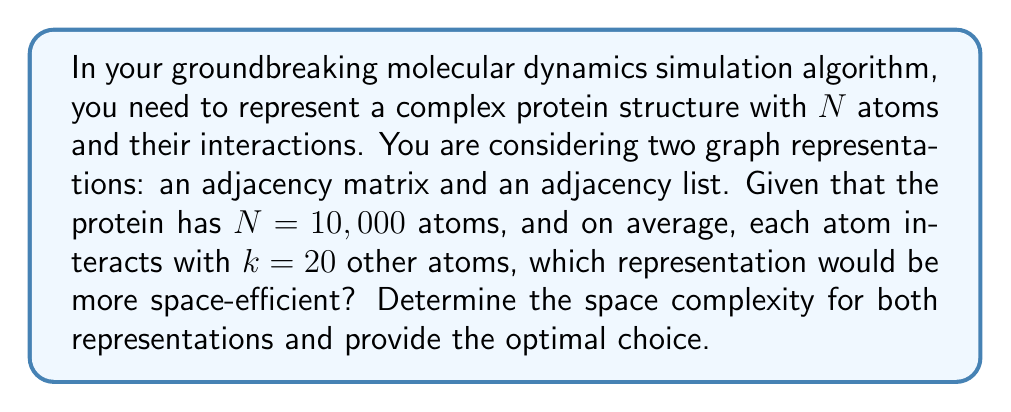Teach me how to tackle this problem. To determine the optimal graph representation, we need to compare the space complexity of adjacency matrix and adjacency list for the given scenario.

1. Adjacency Matrix:
   An adjacency matrix for a graph with $N$ vertices requires $N \times N$ space, regardless of the number of edges.
   Space complexity: $O(N^2)$
   Actual space required: $10,000 \times 10,000 = 10^8$ elements

2. Adjacency List:
   An adjacency list stores a list of adjacent vertices for each vertex. The space required depends on the number of vertices and edges.
   Space complexity: $O(N + E)$, where $E$ is the number of edges
   
   To calculate $E$:
   - Each atom interacts with an average of $k = 20$ other atoms
   - Total interactions: $N \times k = 10,000 \times 20 = 200,000$
   - But this counts each interaction twice (once for each atom involved)
   - So, $E = \frac{N \times k}{2} = \frac{200,000}{2} = 100,000$

   Actual space required: $10,000 + 100,000 = 110,000$ elements

Comparing the two:
- Adjacency Matrix: $10^8$ elements
- Adjacency List: $1.1 \times 10^5$ elements

The adjacency list representation requires significantly less space than the adjacency matrix for this sparse graph (where $E \ll N^2$).
Answer: The optimal graph representation for modeling molecular interactions in this case is the adjacency list, with a space complexity of $O(N + E)$. It requires approximately $1.1 \times 10^5$ elements, which is much more space-efficient than the adjacency matrix representation requiring $10^8$ elements. 